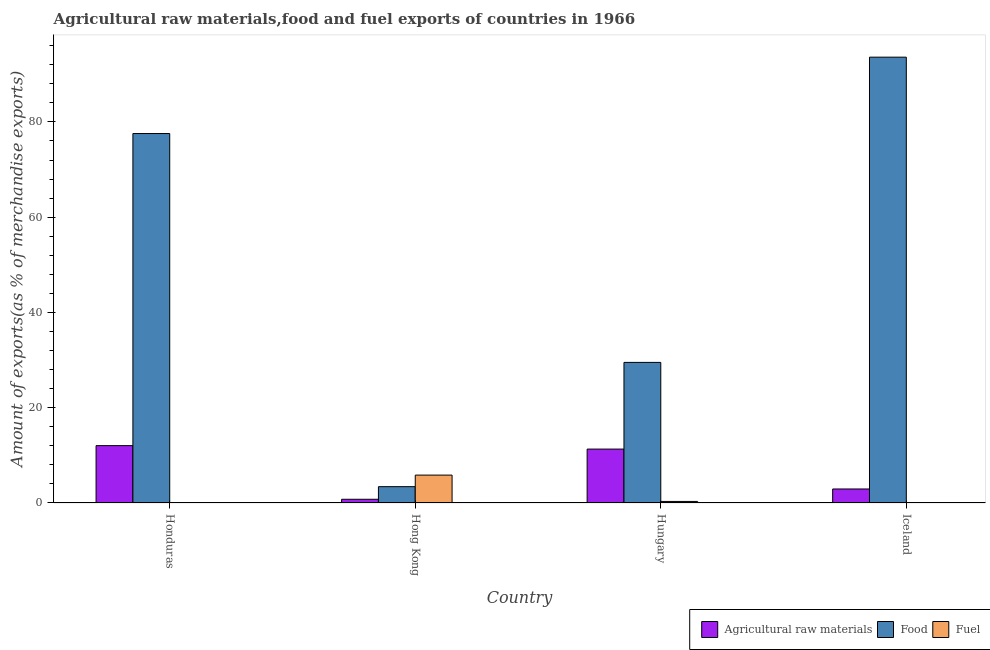How many different coloured bars are there?
Your answer should be very brief. 3. Are the number of bars on each tick of the X-axis equal?
Offer a very short reply. Yes. In how many cases, is the number of bars for a given country not equal to the number of legend labels?
Your answer should be compact. 0. What is the percentage of food exports in Hungary?
Provide a short and direct response. 29.51. Across all countries, what is the maximum percentage of food exports?
Ensure brevity in your answer.  93.59. Across all countries, what is the minimum percentage of raw materials exports?
Keep it short and to the point. 0.78. In which country was the percentage of raw materials exports minimum?
Give a very brief answer. Hong Kong. What is the total percentage of raw materials exports in the graph?
Provide a short and direct response. 27.08. What is the difference between the percentage of raw materials exports in Honduras and that in Hungary?
Provide a short and direct response. 0.73. What is the difference between the percentage of raw materials exports in Hungary and the percentage of fuel exports in Honduras?
Your answer should be compact. 11.28. What is the average percentage of raw materials exports per country?
Provide a succinct answer. 6.77. What is the difference between the percentage of raw materials exports and percentage of fuel exports in Iceland?
Offer a terse response. 2.91. What is the ratio of the percentage of raw materials exports in Hong Kong to that in Iceland?
Your answer should be very brief. 0.27. Is the percentage of fuel exports in Honduras less than that in Hungary?
Ensure brevity in your answer.  Yes. Is the difference between the percentage of fuel exports in Hong Kong and Hungary greater than the difference between the percentage of raw materials exports in Hong Kong and Hungary?
Offer a terse response. Yes. What is the difference between the highest and the second highest percentage of food exports?
Offer a very short reply. 16.03. What is the difference between the highest and the lowest percentage of food exports?
Make the answer very short. 90.17. What does the 2nd bar from the left in Hong Kong represents?
Offer a very short reply. Food. What does the 1st bar from the right in Hong Kong represents?
Provide a short and direct response. Fuel. Is it the case that in every country, the sum of the percentage of raw materials exports and percentage of food exports is greater than the percentage of fuel exports?
Make the answer very short. No. Are all the bars in the graph horizontal?
Ensure brevity in your answer.  No. What is the difference between two consecutive major ticks on the Y-axis?
Provide a succinct answer. 20. How many legend labels are there?
Your answer should be very brief. 3. How are the legend labels stacked?
Ensure brevity in your answer.  Horizontal. What is the title of the graph?
Ensure brevity in your answer.  Agricultural raw materials,food and fuel exports of countries in 1966. Does "Taxes on goods and services" appear as one of the legend labels in the graph?
Offer a very short reply. No. What is the label or title of the X-axis?
Make the answer very short. Country. What is the label or title of the Y-axis?
Offer a very short reply. Amount of exports(as % of merchandise exports). What is the Amount of exports(as % of merchandise exports) of Agricultural raw materials in Honduras?
Make the answer very short. 12.04. What is the Amount of exports(as % of merchandise exports) of Food in Honduras?
Your answer should be compact. 77.56. What is the Amount of exports(as % of merchandise exports) of Fuel in Honduras?
Offer a very short reply. 0.04. What is the Amount of exports(as % of merchandise exports) in Agricultural raw materials in Hong Kong?
Your answer should be very brief. 0.78. What is the Amount of exports(as % of merchandise exports) in Food in Hong Kong?
Keep it short and to the point. 3.43. What is the Amount of exports(as % of merchandise exports) of Fuel in Hong Kong?
Keep it short and to the point. 5.85. What is the Amount of exports(as % of merchandise exports) in Agricultural raw materials in Hungary?
Offer a terse response. 11.31. What is the Amount of exports(as % of merchandise exports) of Food in Hungary?
Your response must be concise. 29.51. What is the Amount of exports(as % of merchandise exports) of Fuel in Hungary?
Your answer should be compact. 0.32. What is the Amount of exports(as % of merchandise exports) of Agricultural raw materials in Iceland?
Offer a very short reply. 2.94. What is the Amount of exports(as % of merchandise exports) of Food in Iceland?
Give a very brief answer. 93.59. What is the Amount of exports(as % of merchandise exports) in Fuel in Iceland?
Your response must be concise. 0.03. Across all countries, what is the maximum Amount of exports(as % of merchandise exports) in Agricultural raw materials?
Your answer should be very brief. 12.04. Across all countries, what is the maximum Amount of exports(as % of merchandise exports) of Food?
Your response must be concise. 93.59. Across all countries, what is the maximum Amount of exports(as % of merchandise exports) in Fuel?
Your response must be concise. 5.85. Across all countries, what is the minimum Amount of exports(as % of merchandise exports) of Agricultural raw materials?
Your answer should be very brief. 0.78. Across all countries, what is the minimum Amount of exports(as % of merchandise exports) in Food?
Your answer should be very brief. 3.43. Across all countries, what is the minimum Amount of exports(as % of merchandise exports) of Fuel?
Your answer should be very brief. 0.03. What is the total Amount of exports(as % of merchandise exports) of Agricultural raw materials in the graph?
Make the answer very short. 27.08. What is the total Amount of exports(as % of merchandise exports) of Food in the graph?
Ensure brevity in your answer.  204.09. What is the total Amount of exports(as % of merchandise exports) of Fuel in the graph?
Your answer should be compact. 6.25. What is the difference between the Amount of exports(as % of merchandise exports) in Agricultural raw materials in Honduras and that in Hong Kong?
Your answer should be very brief. 11.26. What is the difference between the Amount of exports(as % of merchandise exports) in Food in Honduras and that in Hong Kong?
Offer a very short reply. 74.13. What is the difference between the Amount of exports(as % of merchandise exports) of Fuel in Honduras and that in Hong Kong?
Your response must be concise. -5.82. What is the difference between the Amount of exports(as % of merchandise exports) of Agricultural raw materials in Honduras and that in Hungary?
Offer a terse response. 0.73. What is the difference between the Amount of exports(as % of merchandise exports) of Food in Honduras and that in Hungary?
Keep it short and to the point. 48.04. What is the difference between the Amount of exports(as % of merchandise exports) in Fuel in Honduras and that in Hungary?
Offer a terse response. -0.29. What is the difference between the Amount of exports(as % of merchandise exports) in Agricultural raw materials in Honduras and that in Iceland?
Your response must be concise. 9.1. What is the difference between the Amount of exports(as % of merchandise exports) in Food in Honduras and that in Iceland?
Offer a terse response. -16.03. What is the difference between the Amount of exports(as % of merchandise exports) in Fuel in Honduras and that in Iceland?
Keep it short and to the point. 0. What is the difference between the Amount of exports(as % of merchandise exports) of Agricultural raw materials in Hong Kong and that in Hungary?
Provide a short and direct response. -10.53. What is the difference between the Amount of exports(as % of merchandise exports) of Food in Hong Kong and that in Hungary?
Make the answer very short. -26.09. What is the difference between the Amount of exports(as % of merchandise exports) in Fuel in Hong Kong and that in Hungary?
Ensure brevity in your answer.  5.53. What is the difference between the Amount of exports(as % of merchandise exports) of Agricultural raw materials in Hong Kong and that in Iceland?
Give a very brief answer. -2.16. What is the difference between the Amount of exports(as % of merchandise exports) of Food in Hong Kong and that in Iceland?
Provide a short and direct response. -90.17. What is the difference between the Amount of exports(as % of merchandise exports) in Fuel in Hong Kong and that in Iceland?
Offer a terse response. 5.82. What is the difference between the Amount of exports(as % of merchandise exports) in Agricultural raw materials in Hungary and that in Iceland?
Your answer should be very brief. 8.37. What is the difference between the Amount of exports(as % of merchandise exports) in Food in Hungary and that in Iceland?
Your response must be concise. -64.08. What is the difference between the Amount of exports(as % of merchandise exports) in Fuel in Hungary and that in Iceland?
Your answer should be compact. 0.29. What is the difference between the Amount of exports(as % of merchandise exports) of Agricultural raw materials in Honduras and the Amount of exports(as % of merchandise exports) of Food in Hong Kong?
Make the answer very short. 8.62. What is the difference between the Amount of exports(as % of merchandise exports) of Agricultural raw materials in Honduras and the Amount of exports(as % of merchandise exports) of Fuel in Hong Kong?
Provide a short and direct response. 6.19. What is the difference between the Amount of exports(as % of merchandise exports) of Food in Honduras and the Amount of exports(as % of merchandise exports) of Fuel in Hong Kong?
Ensure brevity in your answer.  71.71. What is the difference between the Amount of exports(as % of merchandise exports) of Agricultural raw materials in Honduras and the Amount of exports(as % of merchandise exports) of Food in Hungary?
Your answer should be compact. -17.47. What is the difference between the Amount of exports(as % of merchandise exports) of Agricultural raw materials in Honduras and the Amount of exports(as % of merchandise exports) of Fuel in Hungary?
Offer a very short reply. 11.72. What is the difference between the Amount of exports(as % of merchandise exports) in Food in Honduras and the Amount of exports(as % of merchandise exports) in Fuel in Hungary?
Your answer should be very brief. 77.24. What is the difference between the Amount of exports(as % of merchandise exports) in Agricultural raw materials in Honduras and the Amount of exports(as % of merchandise exports) in Food in Iceland?
Offer a very short reply. -81.55. What is the difference between the Amount of exports(as % of merchandise exports) in Agricultural raw materials in Honduras and the Amount of exports(as % of merchandise exports) in Fuel in Iceland?
Offer a terse response. 12.01. What is the difference between the Amount of exports(as % of merchandise exports) in Food in Honduras and the Amount of exports(as % of merchandise exports) in Fuel in Iceland?
Ensure brevity in your answer.  77.53. What is the difference between the Amount of exports(as % of merchandise exports) in Agricultural raw materials in Hong Kong and the Amount of exports(as % of merchandise exports) in Food in Hungary?
Provide a short and direct response. -28.73. What is the difference between the Amount of exports(as % of merchandise exports) of Agricultural raw materials in Hong Kong and the Amount of exports(as % of merchandise exports) of Fuel in Hungary?
Provide a short and direct response. 0.46. What is the difference between the Amount of exports(as % of merchandise exports) in Food in Hong Kong and the Amount of exports(as % of merchandise exports) in Fuel in Hungary?
Make the answer very short. 3.1. What is the difference between the Amount of exports(as % of merchandise exports) of Agricultural raw materials in Hong Kong and the Amount of exports(as % of merchandise exports) of Food in Iceland?
Offer a terse response. -92.81. What is the difference between the Amount of exports(as % of merchandise exports) in Agricultural raw materials in Hong Kong and the Amount of exports(as % of merchandise exports) in Fuel in Iceland?
Give a very brief answer. 0.75. What is the difference between the Amount of exports(as % of merchandise exports) in Food in Hong Kong and the Amount of exports(as % of merchandise exports) in Fuel in Iceland?
Make the answer very short. 3.39. What is the difference between the Amount of exports(as % of merchandise exports) in Agricultural raw materials in Hungary and the Amount of exports(as % of merchandise exports) in Food in Iceland?
Give a very brief answer. -82.28. What is the difference between the Amount of exports(as % of merchandise exports) in Agricultural raw materials in Hungary and the Amount of exports(as % of merchandise exports) in Fuel in Iceland?
Give a very brief answer. 11.28. What is the difference between the Amount of exports(as % of merchandise exports) in Food in Hungary and the Amount of exports(as % of merchandise exports) in Fuel in Iceland?
Give a very brief answer. 29.48. What is the average Amount of exports(as % of merchandise exports) in Agricultural raw materials per country?
Ensure brevity in your answer.  6.77. What is the average Amount of exports(as % of merchandise exports) of Food per country?
Ensure brevity in your answer.  51.02. What is the average Amount of exports(as % of merchandise exports) of Fuel per country?
Your answer should be very brief. 1.56. What is the difference between the Amount of exports(as % of merchandise exports) of Agricultural raw materials and Amount of exports(as % of merchandise exports) of Food in Honduras?
Give a very brief answer. -65.52. What is the difference between the Amount of exports(as % of merchandise exports) of Agricultural raw materials and Amount of exports(as % of merchandise exports) of Fuel in Honduras?
Offer a very short reply. 12.01. What is the difference between the Amount of exports(as % of merchandise exports) in Food and Amount of exports(as % of merchandise exports) in Fuel in Honduras?
Offer a very short reply. 77.52. What is the difference between the Amount of exports(as % of merchandise exports) of Agricultural raw materials and Amount of exports(as % of merchandise exports) of Food in Hong Kong?
Give a very brief answer. -2.64. What is the difference between the Amount of exports(as % of merchandise exports) in Agricultural raw materials and Amount of exports(as % of merchandise exports) in Fuel in Hong Kong?
Give a very brief answer. -5.07. What is the difference between the Amount of exports(as % of merchandise exports) of Food and Amount of exports(as % of merchandise exports) of Fuel in Hong Kong?
Give a very brief answer. -2.43. What is the difference between the Amount of exports(as % of merchandise exports) in Agricultural raw materials and Amount of exports(as % of merchandise exports) in Food in Hungary?
Keep it short and to the point. -18.2. What is the difference between the Amount of exports(as % of merchandise exports) of Agricultural raw materials and Amount of exports(as % of merchandise exports) of Fuel in Hungary?
Keep it short and to the point. 10.99. What is the difference between the Amount of exports(as % of merchandise exports) of Food and Amount of exports(as % of merchandise exports) of Fuel in Hungary?
Give a very brief answer. 29.19. What is the difference between the Amount of exports(as % of merchandise exports) in Agricultural raw materials and Amount of exports(as % of merchandise exports) in Food in Iceland?
Your answer should be very brief. -90.65. What is the difference between the Amount of exports(as % of merchandise exports) in Agricultural raw materials and Amount of exports(as % of merchandise exports) in Fuel in Iceland?
Offer a very short reply. 2.91. What is the difference between the Amount of exports(as % of merchandise exports) in Food and Amount of exports(as % of merchandise exports) in Fuel in Iceland?
Offer a terse response. 93.56. What is the ratio of the Amount of exports(as % of merchandise exports) in Agricultural raw materials in Honduras to that in Hong Kong?
Offer a terse response. 15.42. What is the ratio of the Amount of exports(as % of merchandise exports) in Food in Honduras to that in Hong Kong?
Offer a terse response. 22.64. What is the ratio of the Amount of exports(as % of merchandise exports) in Fuel in Honduras to that in Hong Kong?
Your answer should be very brief. 0.01. What is the ratio of the Amount of exports(as % of merchandise exports) in Agricultural raw materials in Honduras to that in Hungary?
Give a very brief answer. 1.06. What is the ratio of the Amount of exports(as % of merchandise exports) of Food in Honduras to that in Hungary?
Make the answer very short. 2.63. What is the ratio of the Amount of exports(as % of merchandise exports) in Fuel in Honduras to that in Hungary?
Provide a succinct answer. 0.11. What is the ratio of the Amount of exports(as % of merchandise exports) of Agricultural raw materials in Honduras to that in Iceland?
Offer a terse response. 4.09. What is the ratio of the Amount of exports(as % of merchandise exports) of Food in Honduras to that in Iceland?
Your answer should be compact. 0.83. What is the ratio of the Amount of exports(as % of merchandise exports) in Fuel in Honduras to that in Iceland?
Ensure brevity in your answer.  1.04. What is the ratio of the Amount of exports(as % of merchandise exports) in Agricultural raw materials in Hong Kong to that in Hungary?
Make the answer very short. 0.07. What is the ratio of the Amount of exports(as % of merchandise exports) in Food in Hong Kong to that in Hungary?
Your response must be concise. 0.12. What is the ratio of the Amount of exports(as % of merchandise exports) of Fuel in Hong Kong to that in Hungary?
Your response must be concise. 18.05. What is the ratio of the Amount of exports(as % of merchandise exports) of Agricultural raw materials in Hong Kong to that in Iceland?
Your answer should be very brief. 0.27. What is the ratio of the Amount of exports(as % of merchandise exports) in Food in Hong Kong to that in Iceland?
Offer a very short reply. 0.04. What is the ratio of the Amount of exports(as % of merchandise exports) of Fuel in Hong Kong to that in Iceland?
Ensure brevity in your answer.  170.84. What is the ratio of the Amount of exports(as % of merchandise exports) in Agricultural raw materials in Hungary to that in Iceland?
Give a very brief answer. 3.85. What is the ratio of the Amount of exports(as % of merchandise exports) of Food in Hungary to that in Iceland?
Provide a short and direct response. 0.32. What is the ratio of the Amount of exports(as % of merchandise exports) in Fuel in Hungary to that in Iceland?
Keep it short and to the point. 9.46. What is the difference between the highest and the second highest Amount of exports(as % of merchandise exports) of Agricultural raw materials?
Your response must be concise. 0.73. What is the difference between the highest and the second highest Amount of exports(as % of merchandise exports) in Food?
Ensure brevity in your answer.  16.03. What is the difference between the highest and the second highest Amount of exports(as % of merchandise exports) in Fuel?
Make the answer very short. 5.53. What is the difference between the highest and the lowest Amount of exports(as % of merchandise exports) in Agricultural raw materials?
Keep it short and to the point. 11.26. What is the difference between the highest and the lowest Amount of exports(as % of merchandise exports) in Food?
Your answer should be compact. 90.17. What is the difference between the highest and the lowest Amount of exports(as % of merchandise exports) in Fuel?
Offer a very short reply. 5.82. 